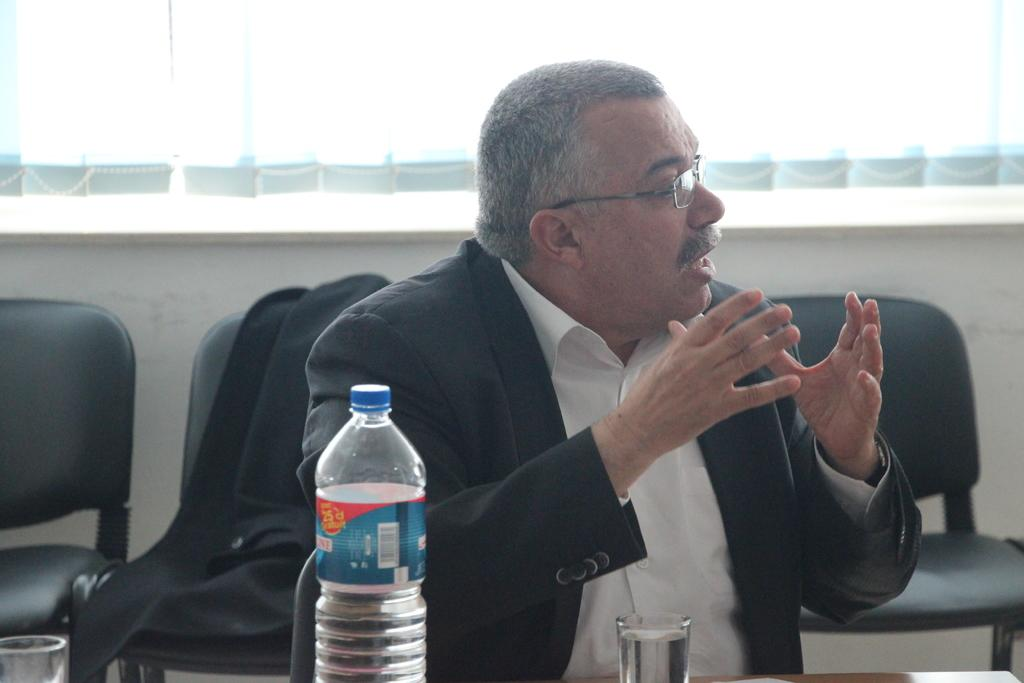What is the person in the image wearing? The person is wearing a black suit in the image. What is the person doing in the image? The person is speaking in the image. What objects are in front of the person? There is a bottle and a glass of water in front of the person. What can be seen in the background of the image? There are black chairs in the background of the image. What type of destruction is the person causing in the image? There is no destruction present in the image; the person is simply speaking. What disease is the person suffering from in the image? There is no indication of any disease in the image; the person is wearing a black suit and speaking. 